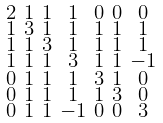<formula> <loc_0><loc_0><loc_500><loc_500>\begin{smallmatrix} 2 & 1 & 1 & 1 & 0 & 0 & 0 \\ 1 & 3 & 1 & 1 & 1 & 1 & 1 \\ 1 & 1 & 3 & 1 & 1 & 1 & 1 \\ 1 & 1 & 1 & 3 & 1 & 1 & - 1 \\ 0 & 1 & 1 & 1 & 3 & 1 & 0 \\ 0 & 1 & 1 & 1 & 1 & 3 & 0 \\ 0 & 1 & 1 & - 1 & 0 & 0 & 3 \end{smallmatrix}</formula> 